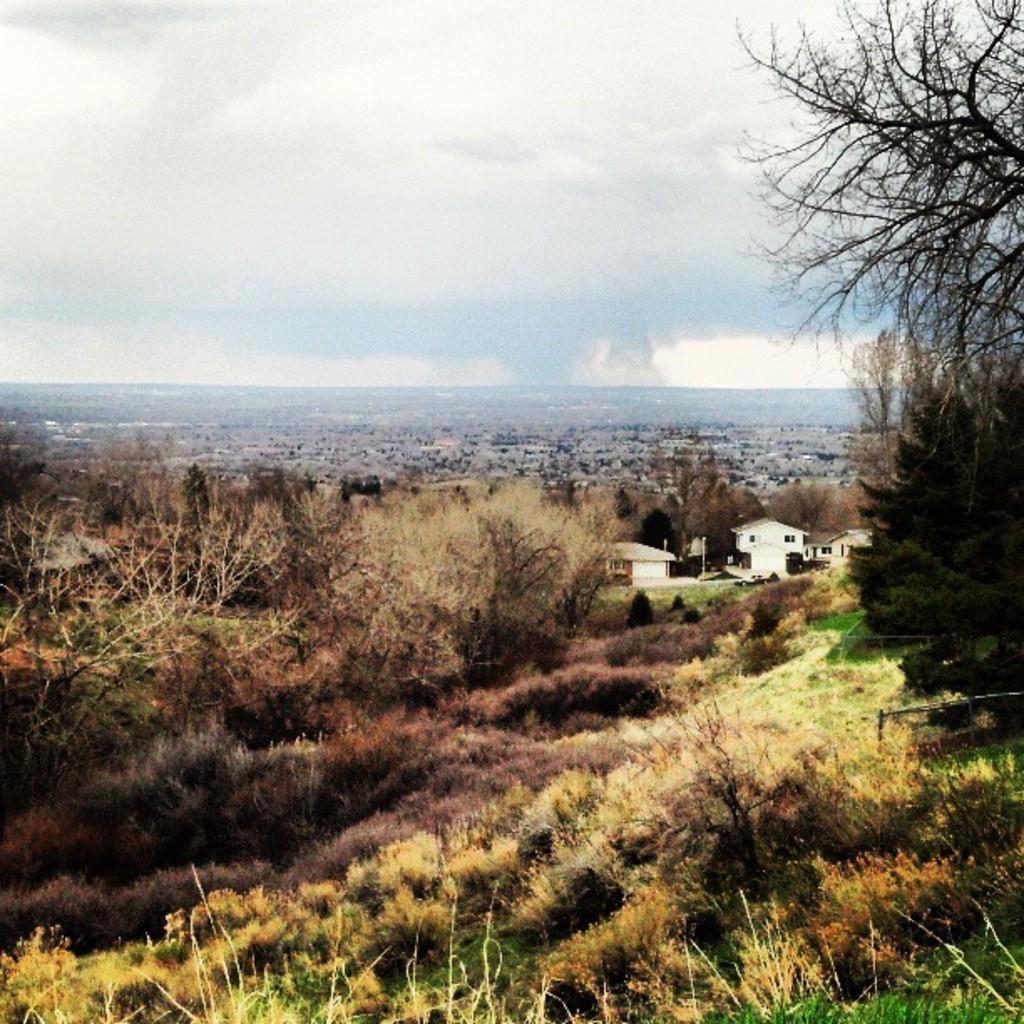How would you summarize this image in a sentence or two? In this image there are trees and plants. In the back there are buildings. In the background there is sky with clouds. 